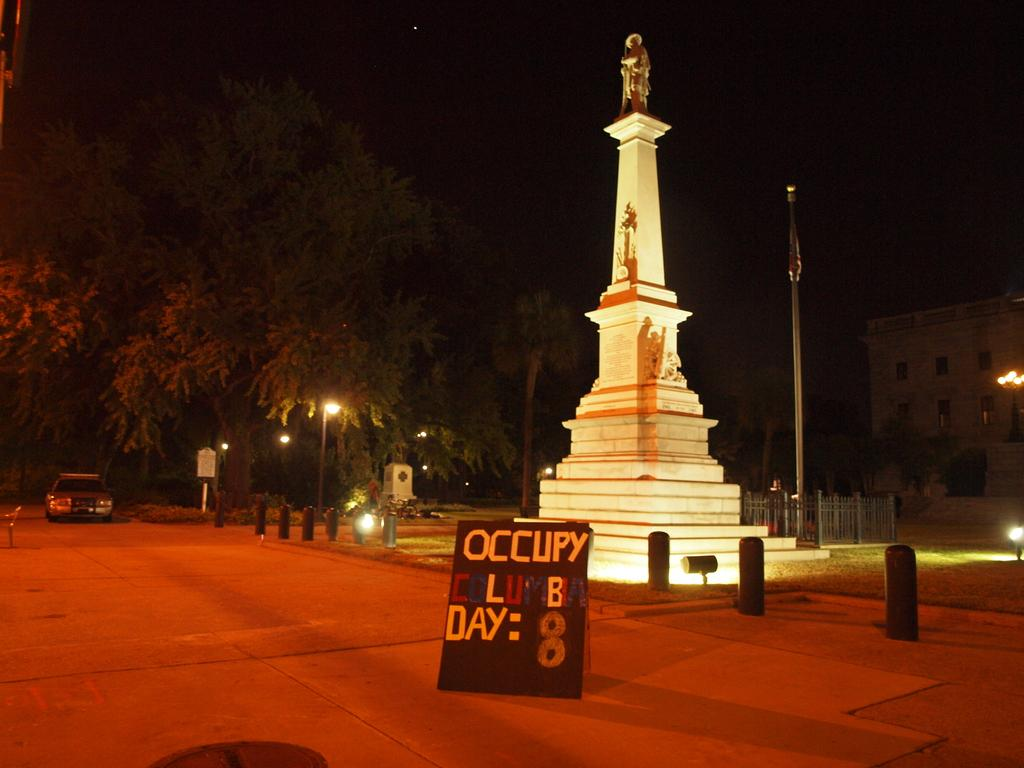<image>
Offer a succinct explanation of the picture presented. An occupy protester sign is placed in front of a large, well lit and narrow statue. 